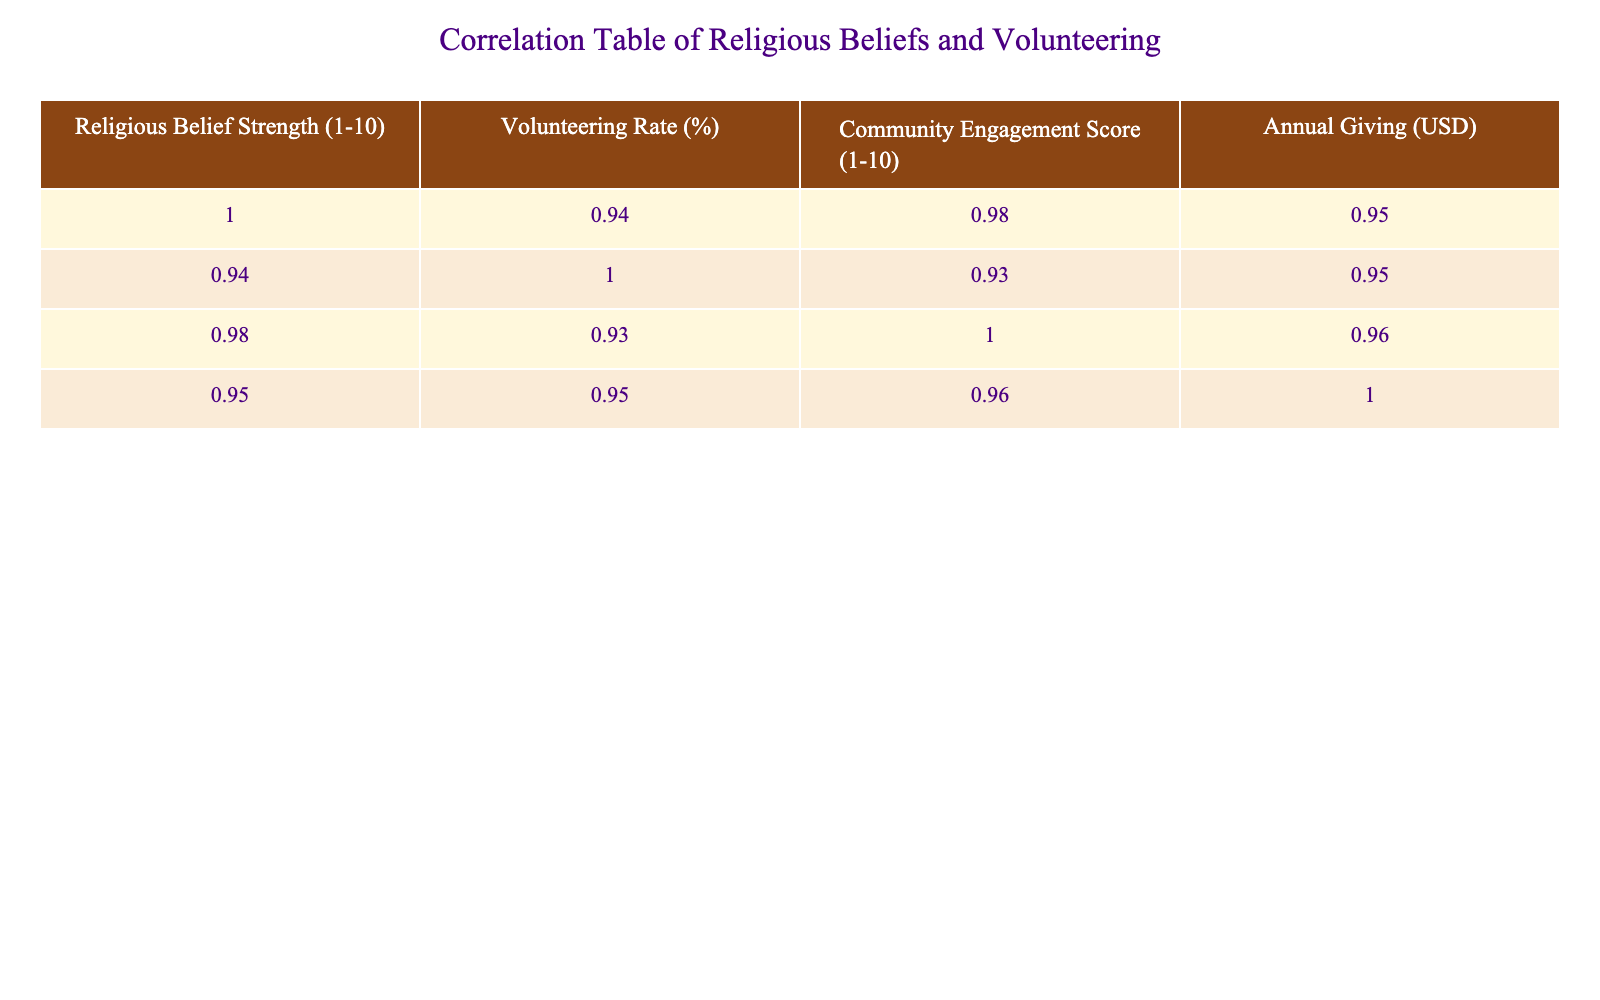What is the volunteering rate for Judaism? The volunteering rate for Judaism can be found directly in the table under the "Volunteering Rate (%)" column corresponding to the "Judaism" row. It states 80%.
Answer: 80% Which faith group has the highest religious belief strength? From the "Religious Belief Strength (1-10)" column, we notice that Judaism has the highest score of 9.
Answer: Judaism What is the difference in volunteering rates between Christianity and Atheism? We find the volunteering rate for Christianity is 65% and for Atheism is 30%. The difference is calculated as 65 - 30 = 35%.
Answer: 35% Is it true that Hinduism has a higher volunteering rate than Taoism? Looking at the "Volunteering Rate (%)" column, Hinduism has a rate of 50% while Taoism has 40%. Since 50 is greater than 40, the statement is true.
Answer: Yes What is the average annual giving for the faith groups that have a volunteering rate greater than 60%? First, identify the faith groups with a volunteering rate greater than 60%, which are Judaism (80%), Islam (70%), and Sikhism (75%). Their annual giving amounts are 1500, 900, and 1100 respectively. Summing these gives 1500 + 900 + 1100 = 3500. There are 3 groups, so the average is 3500 / 3 = approximately 1166.67.
Answer: 1166.67 Which faith group shows the least community engagement? Checking the "Community Engagement Score (1-10)" column reveals that Atheism has the lowest score of 4.
Answer: Atheism Is the correlation between religious belief strength and volunteering rate positive or negative? Analyzing the correlation values from the table indicates that an increase in the religious belief strength generally corresponds to an increase in the volunteering rate, suggesting a positive correlation.
Answer: Positive Calculate the median volunteering rate of all faith groups listed. First, list all volunteering rates in order: 30, 35, 40, 45, 50, 55, 65, 70, 75, 80. With 10 data points, the median is the average of the 5th (50) and 6th (55) values: (50 + 55) / 2 = 52.5.
Answer: 52.5 